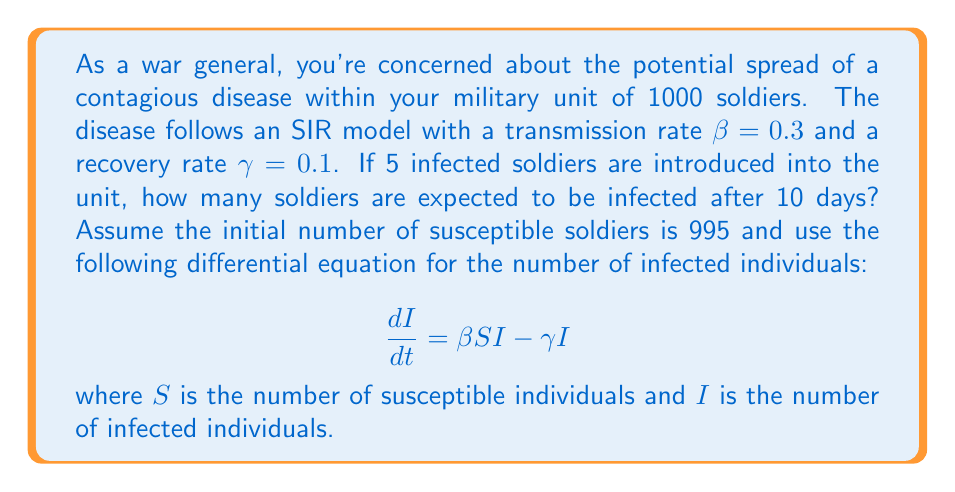Teach me how to tackle this problem. To solve this problem, we need to use the SIR (Susceptible-Infected-Recovered) model and numerical methods to approximate the solution of the differential equation.

1) First, let's set up our initial conditions:
   $S_0 = 995$, $I_0 = 5$, $R_0 = 0$
   $N = S_0 + I_0 + R_0 = 1000$ (total population)
   $\beta = 0.3$, $\gamma = 0.1$, $t = 10$ days

2) The SIR model consists of three differential equations:

   $$ \frac{dS}{dt} = -\beta SI/N $$
   $$ \frac{dI}{dt} = \beta SI/N - \gamma I $$
   $$ \frac{dR}{dt} = \gamma I $$

3) We can use Euler's method to approximate the solution. Let's use a time step of $\Delta t = 0.1$ days.

4) For each time step:
   $S_{t+\Delta t} = S_t - (\beta S_t I_t / N) \Delta t$
   $I_{t+\Delta t} = I_t + (\beta S_t I_t / N - \gamma I_t) \Delta t$
   $R_{t+\Delta t} = R_t + \gamma I_t \Delta t$

5) Implementing this in a programming language or spreadsheet for 100 steps (10 days), we get:

   After 10 days: $S \approx 538$, $I \approx 301$, $R \approx 161$

The exact values may vary slightly depending on the numerical method and step size used.
Answer: Approximately 301 soldiers are expected to be infected after 10 days. 